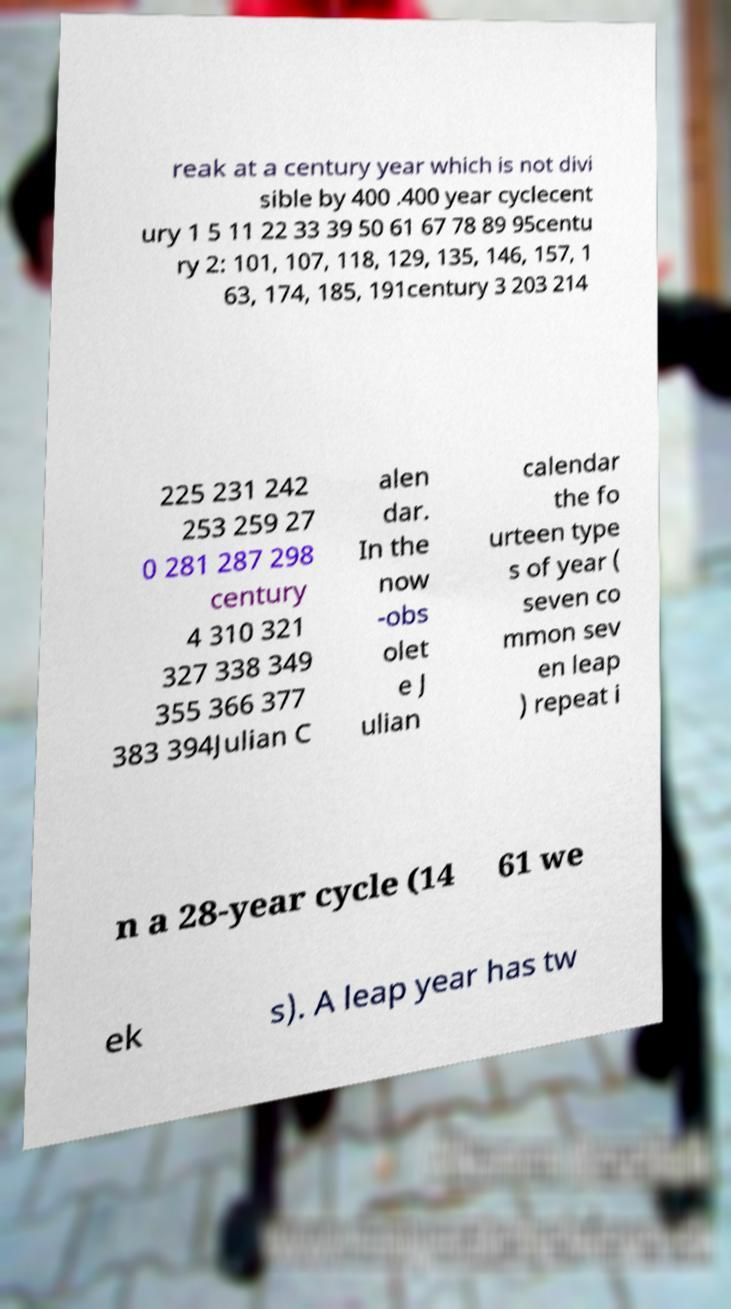Could you assist in decoding the text presented in this image and type it out clearly? reak at a century year which is not divi sible by 400 .400 year cyclecent ury 1 5 11 22 33 39 50 61 67 78 89 95centu ry 2: 101, 107, 118, 129, 135, 146, 157, 1 63, 174, 185, 191century 3 203 214 225 231 242 253 259 27 0 281 287 298 century 4 310 321 327 338 349 355 366 377 383 394Julian C alen dar. In the now -obs olet e J ulian calendar the fo urteen type s of year ( seven co mmon sev en leap ) repeat i n a 28-year cycle (14 61 we ek s). A leap year has tw 